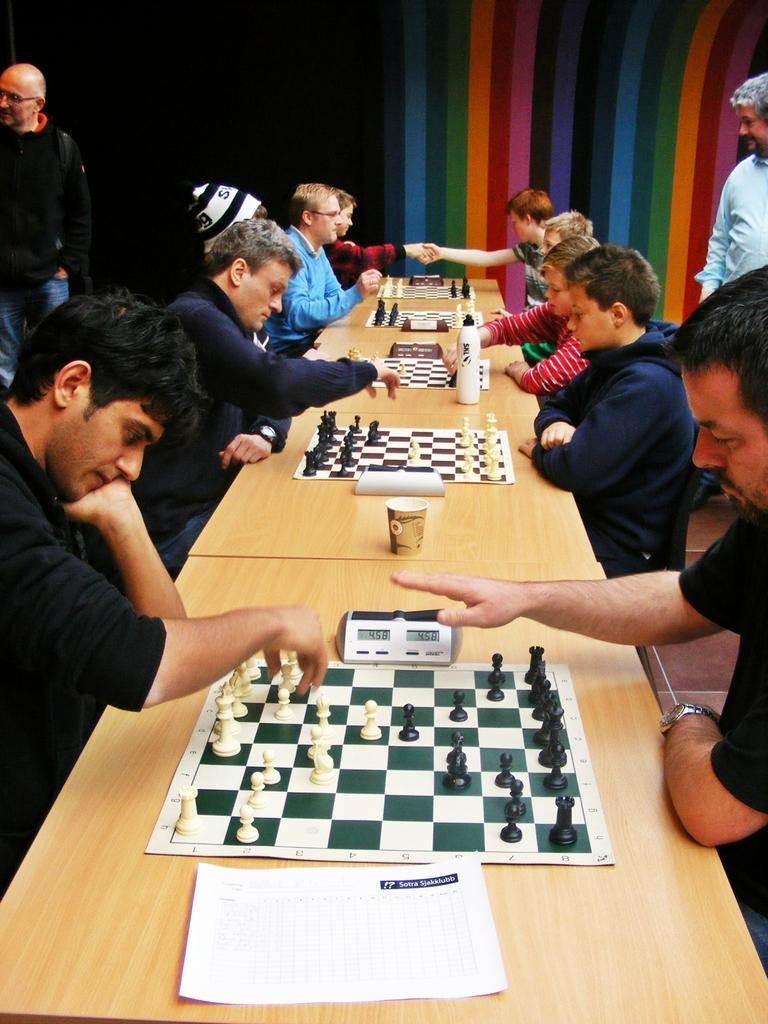What are the individuals in the image doing? The individuals in the image are playing chess. How are the individuals positioned in relation to each other? The individuals are sitting opposite each other. What object can be seen in the image related to timekeeping? There is a clock timer in the image. What type of bear can be seen in the image? There is no bear present in the image. Is there a cable visible in the image? There is no cable visible in the image. 